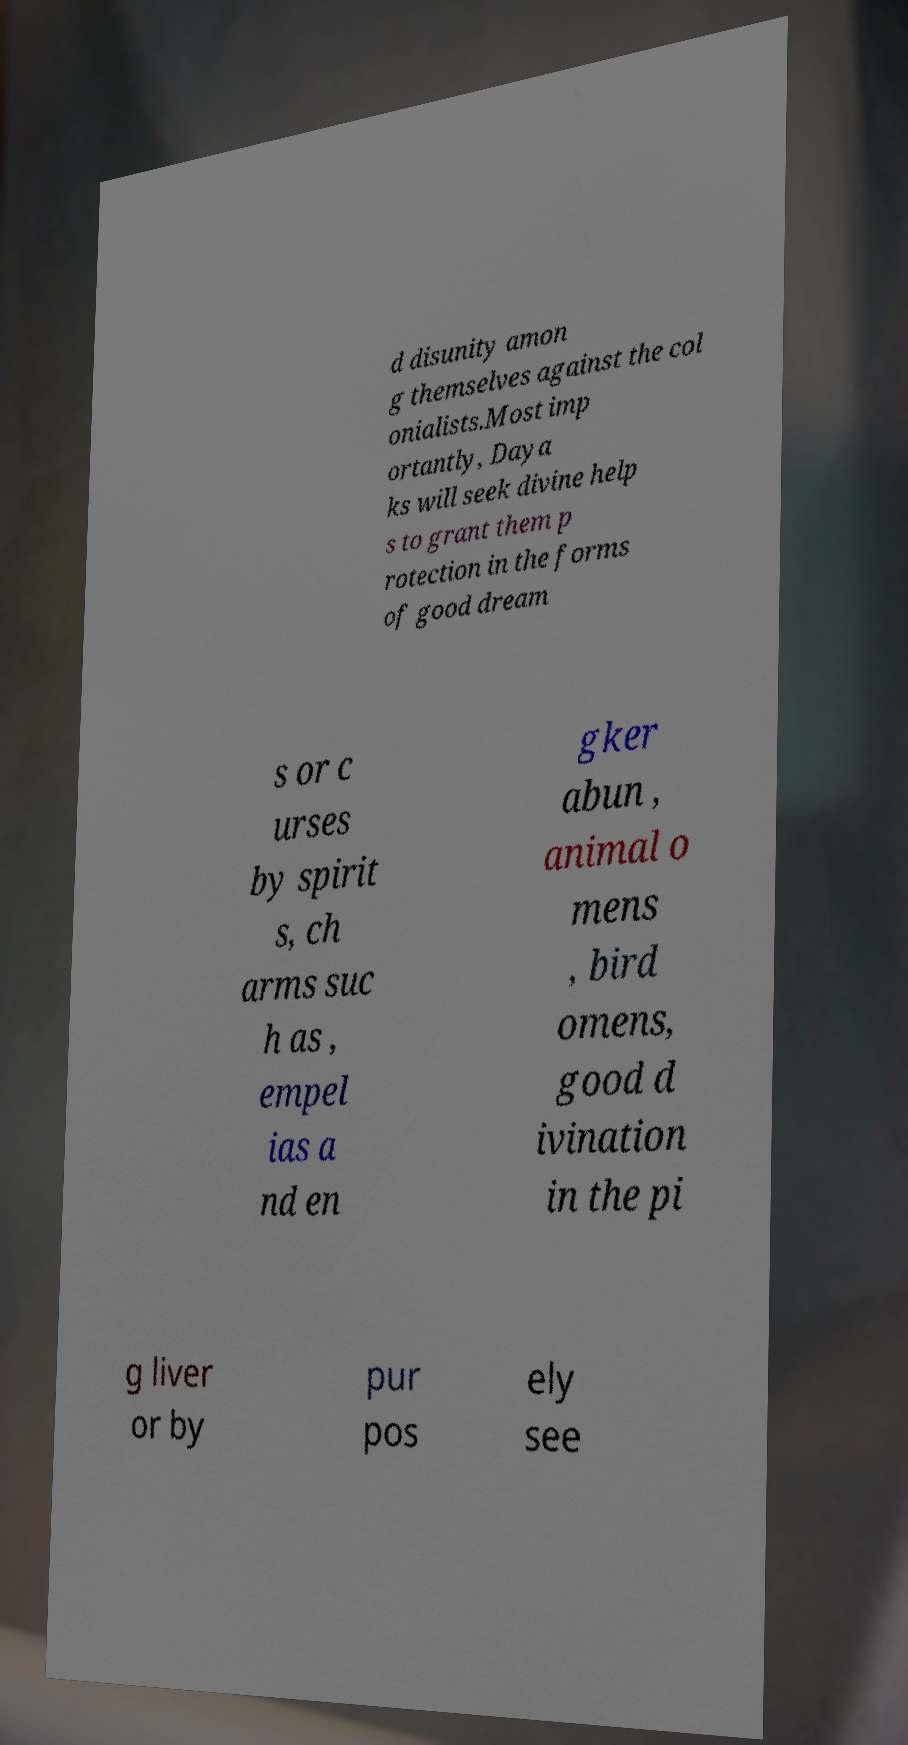There's text embedded in this image that I need extracted. Can you transcribe it verbatim? d disunity amon g themselves against the col onialists.Most imp ortantly, Daya ks will seek divine help s to grant them p rotection in the forms of good dream s or c urses by spirit s, ch arms suc h as , empel ias a nd en gker abun , animal o mens , bird omens, good d ivination in the pi g liver or by pur pos ely see 